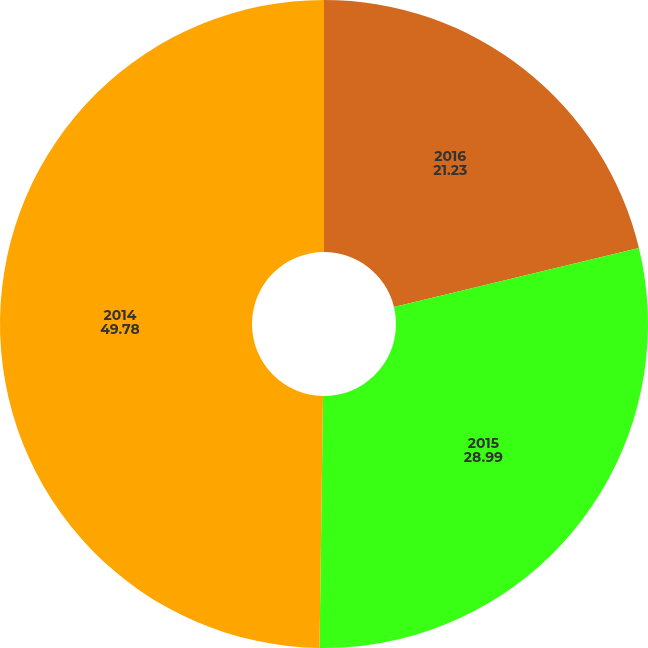<chart> <loc_0><loc_0><loc_500><loc_500><pie_chart><fcel>2016<fcel>2015<fcel>2014<nl><fcel>21.23%<fcel>28.99%<fcel>49.78%<nl></chart> 